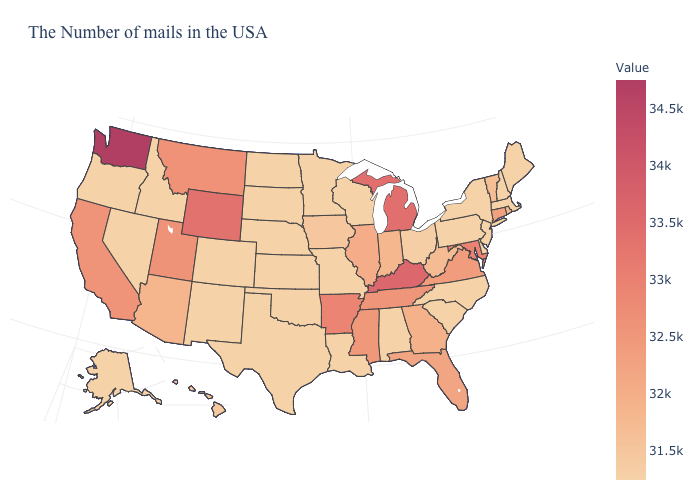Is the legend a continuous bar?
Short answer required. Yes. Does Massachusetts have the highest value in the Northeast?
Keep it brief. No. Which states hav the highest value in the West?
Short answer required. Washington. Is the legend a continuous bar?
Short answer required. Yes. Does the map have missing data?
Be succinct. No. 